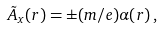<formula> <loc_0><loc_0><loc_500><loc_500>\tilde { A } _ { x } ( { r } ) = \pm ( m / e ) \alpha ( { r } ) \, ,</formula> 